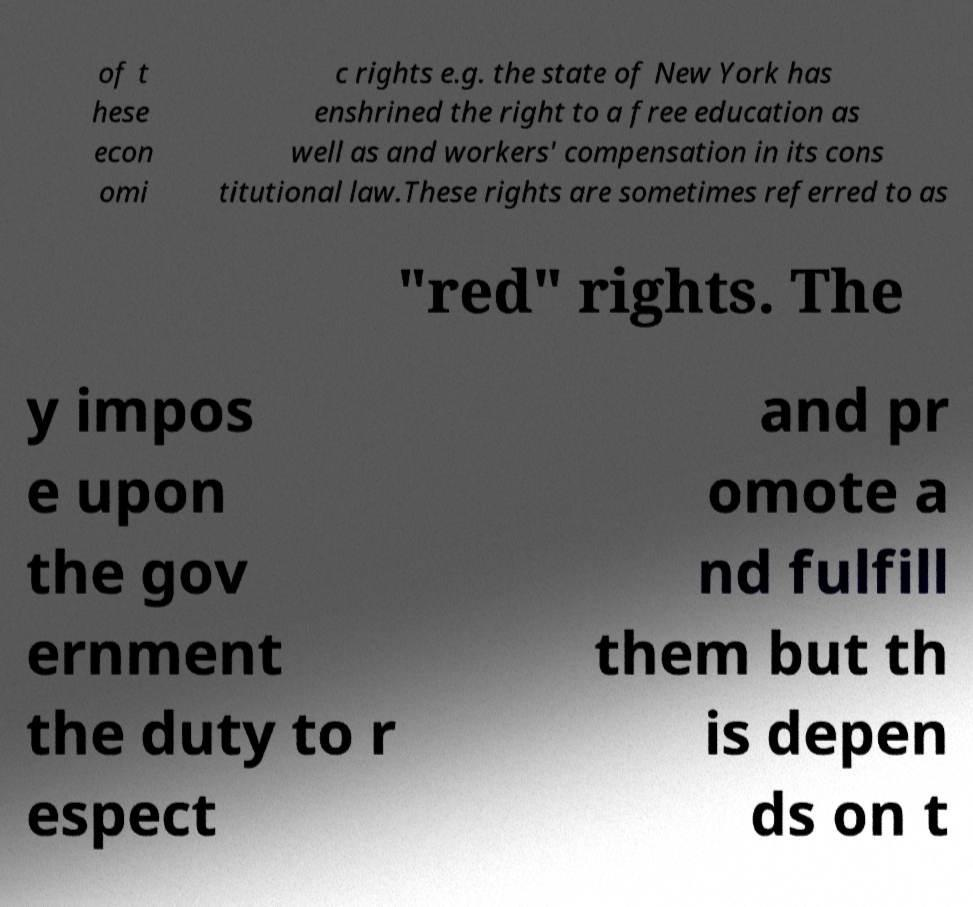Can you accurately transcribe the text from the provided image for me? of t hese econ omi c rights e.g. the state of New York has enshrined the right to a free education as well as and workers' compensation in its cons titutional law.These rights are sometimes referred to as "red" rights. The y impos e upon the gov ernment the duty to r espect and pr omote a nd fulfill them but th is depen ds on t 